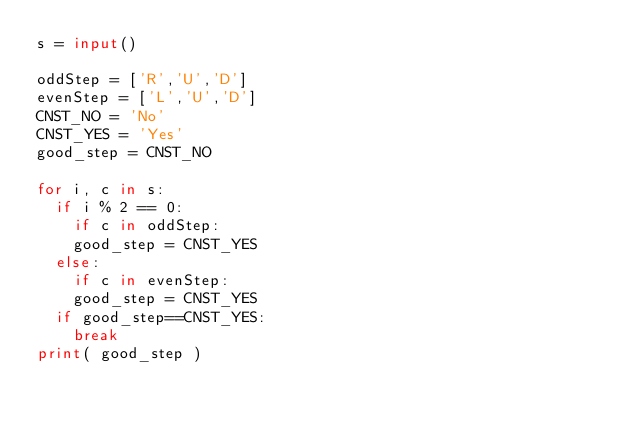Convert code to text. <code><loc_0><loc_0><loc_500><loc_500><_Python_>s = input()

oddStep = ['R','U','D']
evenStep = ['L','U','D']
CNST_NO = 'No'
CNST_YES = 'Yes'
good_step = CNST_NO

for i, c in s:
  if i % 2 == 0:
    if c in oddStep:
		good_step = CNST_YES
  else:
    if c in evenStep:
		good_step = CNST_YES
  if good_step==CNST_YES:
    break
print( good_step )
</code> 